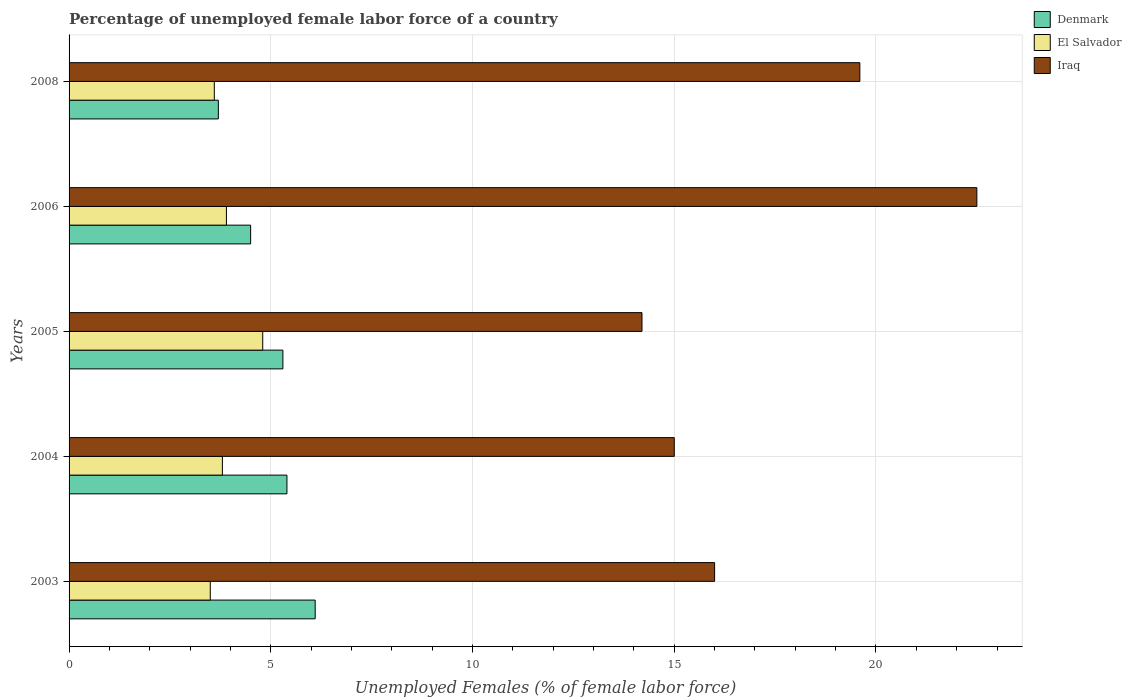Are the number of bars on each tick of the Y-axis equal?
Your answer should be very brief. Yes. How many bars are there on the 4th tick from the top?
Ensure brevity in your answer.  3. How many bars are there on the 5th tick from the bottom?
Your response must be concise. 3. What is the label of the 2nd group of bars from the top?
Offer a very short reply. 2006. In how many cases, is the number of bars for a given year not equal to the number of legend labels?
Give a very brief answer. 0. Across all years, what is the maximum percentage of unemployed female labor force in Denmark?
Provide a succinct answer. 6.1. Across all years, what is the minimum percentage of unemployed female labor force in Iraq?
Provide a short and direct response. 14.2. In which year was the percentage of unemployed female labor force in Denmark maximum?
Your answer should be very brief. 2003. In which year was the percentage of unemployed female labor force in Denmark minimum?
Give a very brief answer. 2008. What is the total percentage of unemployed female labor force in Denmark in the graph?
Your response must be concise. 25. What is the difference between the percentage of unemployed female labor force in Denmark in 2004 and that in 2005?
Your answer should be compact. 0.1. What is the difference between the percentage of unemployed female labor force in Iraq in 2004 and the percentage of unemployed female labor force in Denmark in 2006?
Ensure brevity in your answer.  10.5. What is the average percentage of unemployed female labor force in Denmark per year?
Give a very brief answer. 5. In the year 2005, what is the difference between the percentage of unemployed female labor force in Iraq and percentage of unemployed female labor force in El Salvador?
Your response must be concise. 9.4. In how many years, is the percentage of unemployed female labor force in El Salvador greater than 11 %?
Your answer should be very brief. 0. What is the ratio of the percentage of unemployed female labor force in El Salvador in 2003 to that in 2006?
Offer a very short reply. 0.9. Is the difference between the percentage of unemployed female labor force in Iraq in 2005 and 2008 greater than the difference between the percentage of unemployed female labor force in El Salvador in 2005 and 2008?
Give a very brief answer. No. What is the difference between the highest and the second highest percentage of unemployed female labor force in Iraq?
Ensure brevity in your answer.  2.9. What is the difference between the highest and the lowest percentage of unemployed female labor force in El Salvador?
Make the answer very short. 1.3. What does the 1st bar from the bottom in 2004 represents?
Your answer should be compact. Denmark. Does the graph contain grids?
Your response must be concise. Yes. How many legend labels are there?
Your answer should be very brief. 3. How are the legend labels stacked?
Offer a terse response. Vertical. What is the title of the graph?
Provide a short and direct response. Percentage of unemployed female labor force of a country. Does "Zimbabwe" appear as one of the legend labels in the graph?
Your answer should be very brief. No. What is the label or title of the X-axis?
Give a very brief answer. Unemployed Females (% of female labor force). What is the label or title of the Y-axis?
Your answer should be compact. Years. What is the Unemployed Females (% of female labor force) of Denmark in 2003?
Make the answer very short. 6.1. What is the Unemployed Females (% of female labor force) in Iraq in 2003?
Make the answer very short. 16. What is the Unemployed Females (% of female labor force) of Denmark in 2004?
Ensure brevity in your answer.  5.4. What is the Unemployed Females (% of female labor force) in El Salvador in 2004?
Make the answer very short. 3.8. What is the Unemployed Females (% of female labor force) in Denmark in 2005?
Ensure brevity in your answer.  5.3. What is the Unemployed Females (% of female labor force) in El Salvador in 2005?
Provide a short and direct response. 4.8. What is the Unemployed Females (% of female labor force) of Iraq in 2005?
Offer a very short reply. 14.2. What is the Unemployed Females (% of female labor force) in Denmark in 2006?
Give a very brief answer. 4.5. What is the Unemployed Females (% of female labor force) in El Salvador in 2006?
Make the answer very short. 3.9. What is the Unemployed Females (% of female labor force) in Denmark in 2008?
Give a very brief answer. 3.7. What is the Unemployed Females (% of female labor force) of El Salvador in 2008?
Keep it short and to the point. 3.6. What is the Unemployed Females (% of female labor force) of Iraq in 2008?
Your answer should be very brief. 19.6. Across all years, what is the maximum Unemployed Females (% of female labor force) of Denmark?
Your response must be concise. 6.1. Across all years, what is the maximum Unemployed Females (% of female labor force) of El Salvador?
Offer a terse response. 4.8. Across all years, what is the maximum Unemployed Females (% of female labor force) in Iraq?
Provide a short and direct response. 22.5. Across all years, what is the minimum Unemployed Females (% of female labor force) of Denmark?
Make the answer very short. 3.7. Across all years, what is the minimum Unemployed Females (% of female labor force) in Iraq?
Offer a terse response. 14.2. What is the total Unemployed Females (% of female labor force) of Denmark in the graph?
Ensure brevity in your answer.  25. What is the total Unemployed Females (% of female labor force) of El Salvador in the graph?
Offer a very short reply. 19.6. What is the total Unemployed Females (% of female labor force) in Iraq in the graph?
Offer a terse response. 87.3. What is the difference between the Unemployed Females (% of female labor force) in Denmark in 2003 and that in 2004?
Keep it short and to the point. 0.7. What is the difference between the Unemployed Females (% of female labor force) of Iraq in 2003 and that in 2004?
Offer a terse response. 1. What is the difference between the Unemployed Females (% of female labor force) of El Salvador in 2003 and that in 2005?
Offer a terse response. -1.3. What is the difference between the Unemployed Females (% of female labor force) of Iraq in 2003 and that in 2005?
Offer a very short reply. 1.8. What is the difference between the Unemployed Females (% of female labor force) in El Salvador in 2003 and that in 2006?
Offer a terse response. -0.4. What is the difference between the Unemployed Females (% of female labor force) in Iraq in 2003 and that in 2006?
Offer a terse response. -6.5. What is the difference between the Unemployed Females (% of female labor force) in Denmark in 2003 and that in 2008?
Provide a short and direct response. 2.4. What is the difference between the Unemployed Females (% of female labor force) in El Salvador in 2003 and that in 2008?
Your answer should be very brief. -0.1. What is the difference between the Unemployed Females (% of female labor force) in Iraq in 2003 and that in 2008?
Ensure brevity in your answer.  -3.6. What is the difference between the Unemployed Females (% of female labor force) of El Salvador in 2004 and that in 2005?
Ensure brevity in your answer.  -1. What is the difference between the Unemployed Females (% of female labor force) in Denmark in 2004 and that in 2008?
Give a very brief answer. 1.7. What is the difference between the Unemployed Females (% of female labor force) in El Salvador in 2004 and that in 2008?
Offer a very short reply. 0.2. What is the difference between the Unemployed Females (% of female labor force) of Iraq in 2004 and that in 2008?
Keep it short and to the point. -4.6. What is the difference between the Unemployed Females (% of female labor force) of Denmark in 2005 and that in 2006?
Give a very brief answer. 0.8. What is the difference between the Unemployed Females (% of female labor force) of El Salvador in 2005 and that in 2006?
Keep it short and to the point. 0.9. What is the difference between the Unemployed Females (% of female labor force) in Iraq in 2005 and that in 2006?
Your response must be concise. -8.3. What is the difference between the Unemployed Females (% of female labor force) in Denmark in 2006 and that in 2008?
Your answer should be very brief. 0.8. What is the difference between the Unemployed Females (% of female labor force) of Iraq in 2006 and that in 2008?
Your answer should be very brief. 2.9. What is the difference between the Unemployed Females (% of female labor force) of Denmark in 2003 and the Unemployed Females (% of female labor force) of Iraq in 2004?
Give a very brief answer. -8.9. What is the difference between the Unemployed Females (% of female labor force) in Denmark in 2003 and the Unemployed Females (% of female labor force) in Iraq in 2005?
Make the answer very short. -8.1. What is the difference between the Unemployed Females (% of female labor force) in El Salvador in 2003 and the Unemployed Females (% of female labor force) in Iraq in 2005?
Make the answer very short. -10.7. What is the difference between the Unemployed Females (% of female labor force) in Denmark in 2003 and the Unemployed Females (% of female labor force) in Iraq in 2006?
Provide a short and direct response. -16.4. What is the difference between the Unemployed Females (% of female labor force) of Denmark in 2003 and the Unemployed Females (% of female labor force) of Iraq in 2008?
Provide a short and direct response. -13.5. What is the difference between the Unemployed Females (% of female labor force) of El Salvador in 2003 and the Unemployed Females (% of female labor force) of Iraq in 2008?
Your response must be concise. -16.1. What is the difference between the Unemployed Females (% of female labor force) of Denmark in 2004 and the Unemployed Females (% of female labor force) of El Salvador in 2005?
Make the answer very short. 0.6. What is the difference between the Unemployed Females (% of female labor force) in El Salvador in 2004 and the Unemployed Females (% of female labor force) in Iraq in 2005?
Keep it short and to the point. -10.4. What is the difference between the Unemployed Females (% of female labor force) of Denmark in 2004 and the Unemployed Females (% of female labor force) of El Salvador in 2006?
Make the answer very short. 1.5. What is the difference between the Unemployed Females (% of female labor force) in Denmark in 2004 and the Unemployed Females (% of female labor force) in Iraq in 2006?
Provide a succinct answer. -17.1. What is the difference between the Unemployed Females (% of female labor force) of El Salvador in 2004 and the Unemployed Females (% of female labor force) of Iraq in 2006?
Your answer should be very brief. -18.7. What is the difference between the Unemployed Females (% of female labor force) of Denmark in 2004 and the Unemployed Females (% of female labor force) of Iraq in 2008?
Provide a short and direct response. -14.2. What is the difference between the Unemployed Females (% of female labor force) of El Salvador in 2004 and the Unemployed Females (% of female labor force) of Iraq in 2008?
Keep it short and to the point. -15.8. What is the difference between the Unemployed Females (% of female labor force) in Denmark in 2005 and the Unemployed Females (% of female labor force) in Iraq in 2006?
Make the answer very short. -17.2. What is the difference between the Unemployed Females (% of female labor force) in El Salvador in 2005 and the Unemployed Females (% of female labor force) in Iraq in 2006?
Your answer should be compact. -17.7. What is the difference between the Unemployed Females (% of female labor force) of Denmark in 2005 and the Unemployed Females (% of female labor force) of El Salvador in 2008?
Ensure brevity in your answer.  1.7. What is the difference between the Unemployed Females (% of female labor force) of Denmark in 2005 and the Unemployed Females (% of female labor force) of Iraq in 2008?
Make the answer very short. -14.3. What is the difference between the Unemployed Females (% of female labor force) of El Salvador in 2005 and the Unemployed Females (% of female labor force) of Iraq in 2008?
Provide a short and direct response. -14.8. What is the difference between the Unemployed Females (% of female labor force) of Denmark in 2006 and the Unemployed Females (% of female labor force) of El Salvador in 2008?
Provide a short and direct response. 0.9. What is the difference between the Unemployed Females (% of female labor force) in Denmark in 2006 and the Unemployed Females (% of female labor force) in Iraq in 2008?
Make the answer very short. -15.1. What is the difference between the Unemployed Females (% of female labor force) in El Salvador in 2006 and the Unemployed Females (% of female labor force) in Iraq in 2008?
Give a very brief answer. -15.7. What is the average Unemployed Females (% of female labor force) of Denmark per year?
Your answer should be very brief. 5. What is the average Unemployed Females (% of female labor force) of El Salvador per year?
Ensure brevity in your answer.  3.92. What is the average Unemployed Females (% of female labor force) of Iraq per year?
Your answer should be very brief. 17.46. In the year 2003, what is the difference between the Unemployed Females (% of female labor force) of El Salvador and Unemployed Females (% of female labor force) of Iraq?
Provide a short and direct response. -12.5. In the year 2004, what is the difference between the Unemployed Females (% of female labor force) in Denmark and Unemployed Females (% of female labor force) in El Salvador?
Your response must be concise. 1.6. In the year 2005, what is the difference between the Unemployed Females (% of female labor force) in Denmark and Unemployed Females (% of female labor force) in El Salvador?
Make the answer very short. 0.5. In the year 2005, what is the difference between the Unemployed Females (% of female labor force) of Denmark and Unemployed Females (% of female labor force) of Iraq?
Make the answer very short. -8.9. In the year 2006, what is the difference between the Unemployed Females (% of female labor force) in Denmark and Unemployed Females (% of female labor force) in El Salvador?
Ensure brevity in your answer.  0.6. In the year 2006, what is the difference between the Unemployed Females (% of female labor force) of Denmark and Unemployed Females (% of female labor force) of Iraq?
Keep it short and to the point. -18. In the year 2006, what is the difference between the Unemployed Females (% of female labor force) of El Salvador and Unemployed Females (% of female labor force) of Iraq?
Provide a short and direct response. -18.6. In the year 2008, what is the difference between the Unemployed Females (% of female labor force) of Denmark and Unemployed Females (% of female labor force) of Iraq?
Your answer should be very brief. -15.9. In the year 2008, what is the difference between the Unemployed Females (% of female labor force) in El Salvador and Unemployed Females (% of female labor force) in Iraq?
Make the answer very short. -16. What is the ratio of the Unemployed Females (% of female labor force) of Denmark in 2003 to that in 2004?
Your response must be concise. 1.13. What is the ratio of the Unemployed Females (% of female labor force) of El Salvador in 2003 to that in 2004?
Your response must be concise. 0.92. What is the ratio of the Unemployed Females (% of female labor force) in Iraq in 2003 to that in 2004?
Provide a short and direct response. 1.07. What is the ratio of the Unemployed Females (% of female labor force) of Denmark in 2003 to that in 2005?
Offer a very short reply. 1.15. What is the ratio of the Unemployed Females (% of female labor force) in El Salvador in 2003 to that in 2005?
Keep it short and to the point. 0.73. What is the ratio of the Unemployed Females (% of female labor force) in Iraq in 2003 to that in 2005?
Your answer should be compact. 1.13. What is the ratio of the Unemployed Females (% of female labor force) of Denmark in 2003 to that in 2006?
Your answer should be very brief. 1.36. What is the ratio of the Unemployed Females (% of female labor force) in El Salvador in 2003 to that in 2006?
Your response must be concise. 0.9. What is the ratio of the Unemployed Females (% of female labor force) of Iraq in 2003 to that in 2006?
Ensure brevity in your answer.  0.71. What is the ratio of the Unemployed Females (% of female labor force) of Denmark in 2003 to that in 2008?
Give a very brief answer. 1.65. What is the ratio of the Unemployed Females (% of female labor force) of El Salvador in 2003 to that in 2008?
Your answer should be very brief. 0.97. What is the ratio of the Unemployed Females (% of female labor force) in Iraq in 2003 to that in 2008?
Offer a terse response. 0.82. What is the ratio of the Unemployed Females (% of female labor force) in Denmark in 2004 to that in 2005?
Your answer should be very brief. 1.02. What is the ratio of the Unemployed Females (% of female labor force) in El Salvador in 2004 to that in 2005?
Provide a short and direct response. 0.79. What is the ratio of the Unemployed Females (% of female labor force) of Iraq in 2004 to that in 2005?
Your answer should be very brief. 1.06. What is the ratio of the Unemployed Females (% of female labor force) of El Salvador in 2004 to that in 2006?
Your response must be concise. 0.97. What is the ratio of the Unemployed Females (% of female labor force) of Iraq in 2004 to that in 2006?
Ensure brevity in your answer.  0.67. What is the ratio of the Unemployed Females (% of female labor force) in Denmark in 2004 to that in 2008?
Offer a very short reply. 1.46. What is the ratio of the Unemployed Females (% of female labor force) in El Salvador in 2004 to that in 2008?
Make the answer very short. 1.06. What is the ratio of the Unemployed Females (% of female labor force) of Iraq in 2004 to that in 2008?
Your answer should be compact. 0.77. What is the ratio of the Unemployed Females (% of female labor force) in Denmark in 2005 to that in 2006?
Offer a very short reply. 1.18. What is the ratio of the Unemployed Females (% of female labor force) in El Salvador in 2005 to that in 2006?
Offer a very short reply. 1.23. What is the ratio of the Unemployed Females (% of female labor force) of Iraq in 2005 to that in 2006?
Your response must be concise. 0.63. What is the ratio of the Unemployed Females (% of female labor force) of Denmark in 2005 to that in 2008?
Your answer should be very brief. 1.43. What is the ratio of the Unemployed Females (% of female labor force) of El Salvador in 2005 to that in 2008?
Your response must be concise. 1.33. What is the ratio of the Unemployed Females (% of female labor force) of Iraq in 2005 to that in 2008?
Offer a terse response. 0.72. What is the ratio of the Unemployed Females (% of female labor force) in Denmark in 2006 to that in 2008?
Provide a short and direct response. 1.22. What is the ratio of the Unemployed Females (% of female labor force) in Iraq in 2006 to that in 2008?
Provide a short and direct response. 1.15. What is the difference between the highest and the second highest Unemployed Females (% of female labor force) of El Salvador?
Your answer should be compact. 0.9. What is the difference between the highest and the lowest Unemployed Females (% of female labor force) of El Salvador?
Offer a terse response. 1.3. 